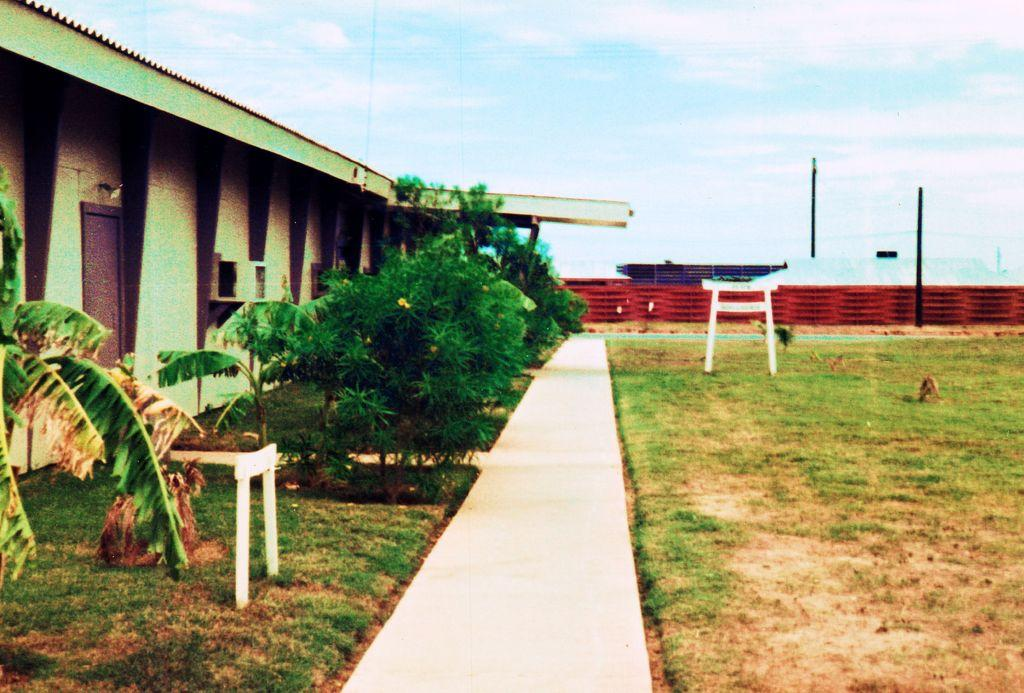What is the primary surface visible in the image? There is a ground in the image. What structure can be seen on the left side of the image? There is a building on the left side of the image. What type of vegetation is also present on the left side of the image? There are trees on the left side of the image. What type of seating is available in the image? There is a bench in the image. What can be seen in the background of the image? The sky, a wall, and a pole are visible in the background of the image. What type of butter is being used to play a game with the judge in the image? There is no butter, game, or judge present in the image. 